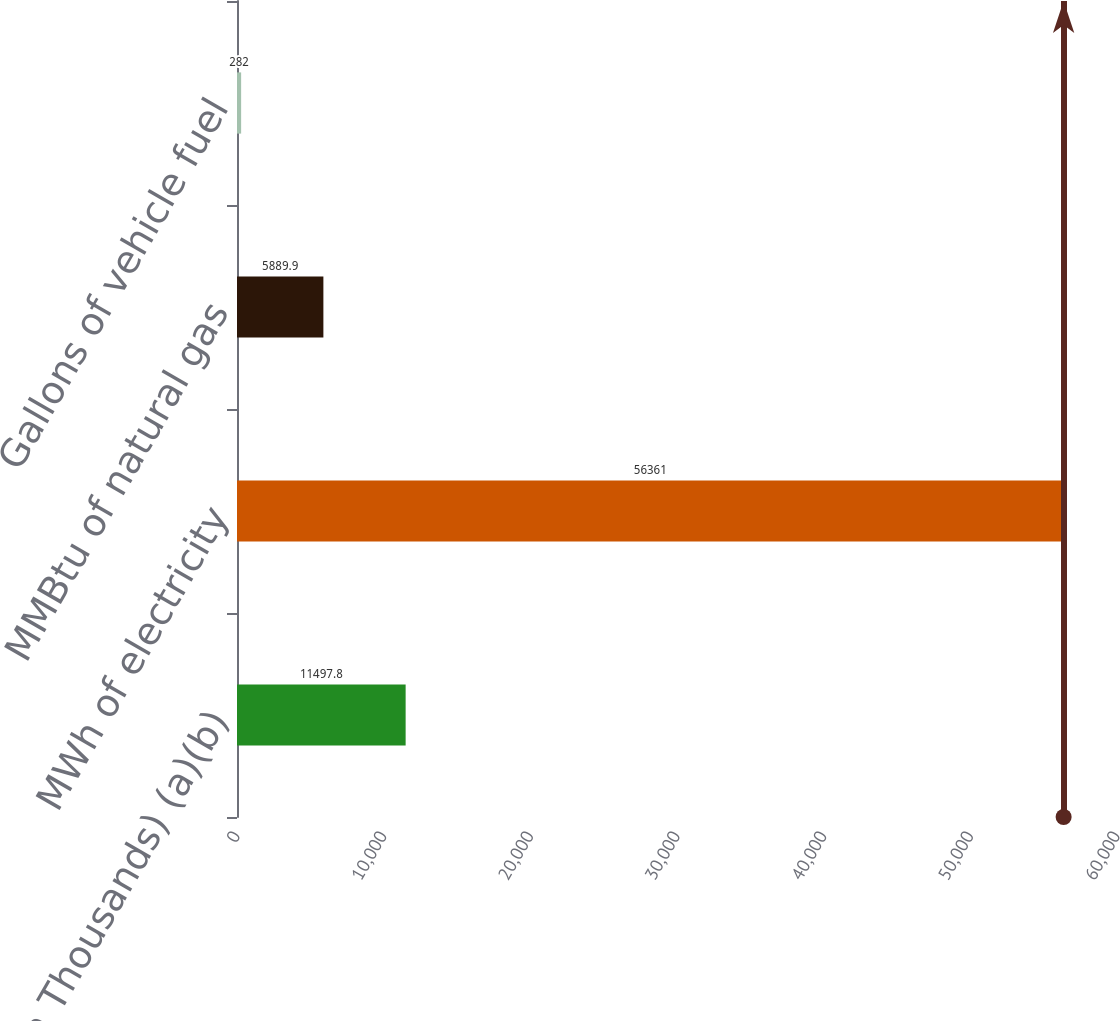<chart> <loc_0><loc_0><loc_500><loc_500><bar_chart><fcel>(Amounts in Thousands) (a)(b)<fcel>MWh of electricity<fcel>MMBtu of natural gas<fcel>Gallons of vehicle fuel<nl><fcel>11497.8<fcel>56361<fcel>5889.9<fcel>282<nl></chart> 